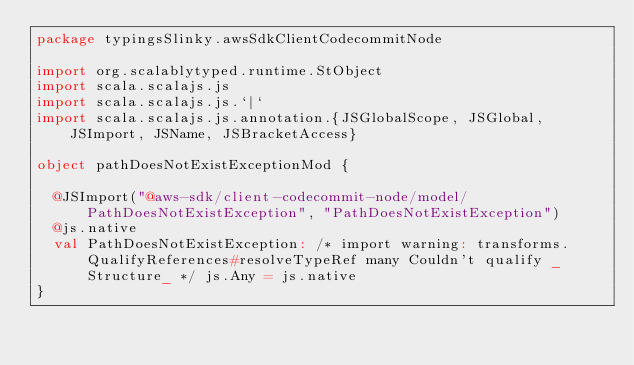Convert code to text. <code><loc_0><loc_0><loc_500><loc_500><_Scala_>package typingsSlinky.awsSdkClientCodecommitNode

import org.scalablytyped.runtime.StObject
import scala.scalajs.js
import scala.scalajs.js.`|`
import scala.scalajs.js.annotation.{JSGlobalScope, JSGlobal, JSImport, JSName, JSBracketAccess}

object pathDoesNotExistExceptionMod {
  
  @JSImport("@aws-sdk/client-codecommit-node/model/PathDoesNotExistException", "PathDoesNotExistException")
  @js.native
  val PathDoesNotExistException: /* import warning: transforms.QualifyReferences#resolveTypeRef many Couldn't qualify _Structure_ */ js.Any = js.native
}
</code> 